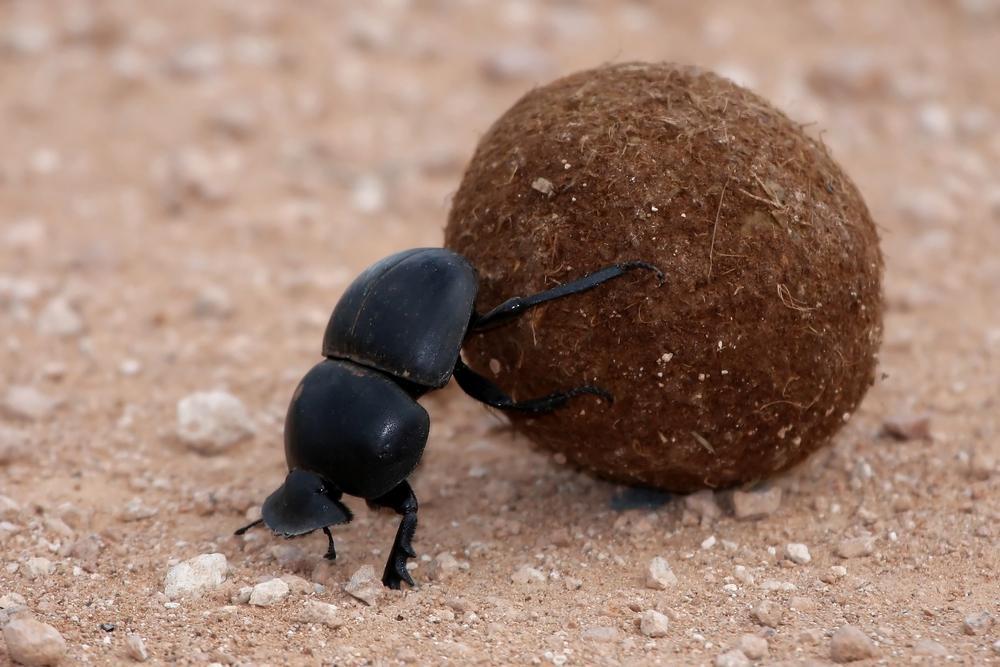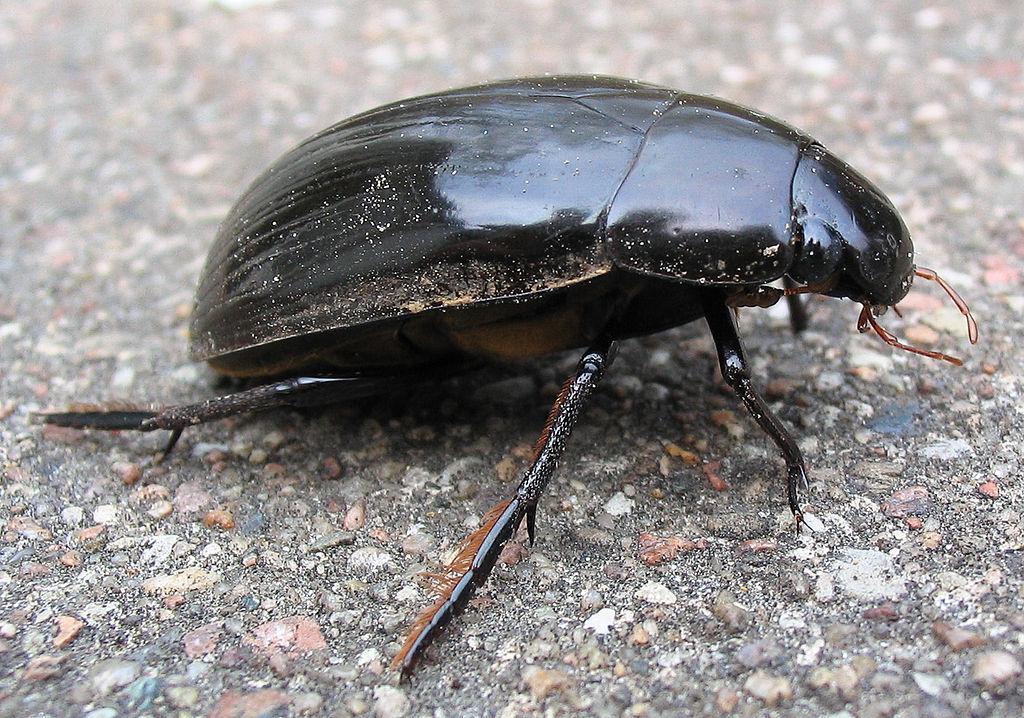The first image is the image on the left, the second image is the image on the right. Analyze the images presented: Is the assertion "There is only one dungball in the image pair." valid? Answer yes or no. Yes. The first image is the image on the left, the second image is the image on the right. Analyze the images presented: Is the assertion "One image shows a beetle but no ball, and the other image shows a beetle partly perched on a ball." valid? Answer yes or no. Yes. 